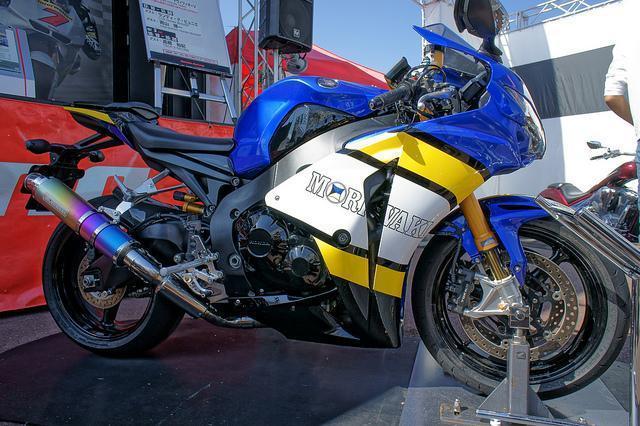How many motorcycles can be seen?
Give a very brief answer. 2. How many bikes are there?
Give a very brief answer. 0. 